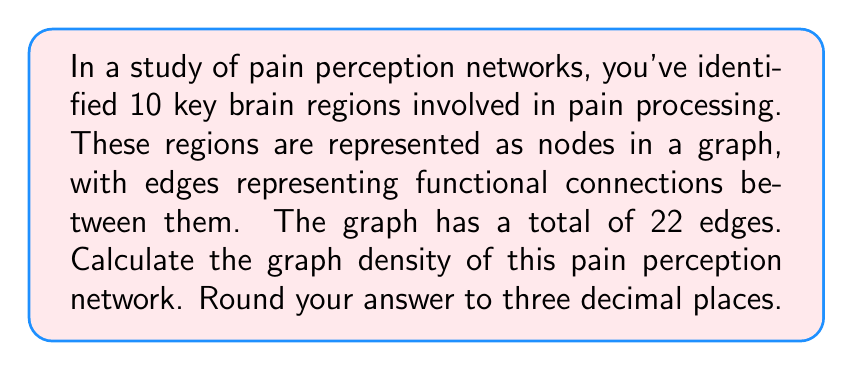Show me your answer to this math problem. To solve this problem, we need to understand the concept of graph density and apply it to the given information. Let's break it down step-by-step:

1. Graph density is a measure of how many edges are in a graph compared to the maximum possible number of edges. It's calculated using the formula:

   $$D = \frac{2|E|}{|V|(|V|-1)}$$

   Where $D$ is the density, $|E|$ is the number of edges, and $|V|$ is the number of vertices (nodes).

2. In this case, we have:
   - Number of nodes (brain regions): $|V| = 10$
   - Number of edges (functional connections): $|E| = 22$

3. The maximum number of possible edges in an undirected graph with 10 nodes is:
   
   $$\frac{|V|(|V|-1)}{2} = \frac{10(10-1)}{2} = \frac{10 \times 9}{2} = 45$$

4. Now, let's plug these values into the density formula:

   $$D = \frac{2|E|}{|V|(|V|-1)} = \frac{2 \times 22}{10 \times 9} = \frac{44}{90}$$

5. Calculating this fraction:
   
   $$\frac{44}{90} \approx 0.4888888889$$

6. Rounding to three decimal places:

   $$0.489$$

This density value indicates that the pain perception network has about 48.9% of all possible connections between the identified brain regions, suggesting a moderately dense network.
Answer: 0.489 